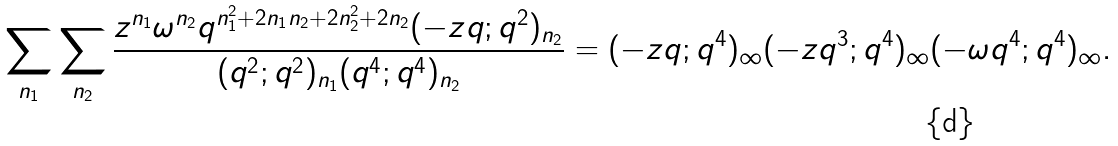Convert formula to latex. <formula><loc_0><loc_0><loc_500><loc_500>\sum _ { n _ { 1 } } \sum _ { n _ { 2 } } \frac { z ^ { n _ { 1 } } { \omega } ^ { n _ { 2 } } q ^ { n ^ { 2 } _ { 1 } + 2 n _ { 1 } n _ { 2 } + 2 n ^ { 2 } _ { 2 } + 2 n _ { 2 } } ( - z q ; q ^ { 2 } ) _ { n _ { 2 } } } { ( q ^ { 2 } ; q ^ { 2 } ) _ { n _ { 1 } } ( q ^ { 4 } ; q ^ { 4 } ) _ { n _ { 2 } } } = ( - z q ; q ^ { 4 } ) _ { \infty } ( - z q ^ { 3 } ; q ^ { 4 } ) _ { \infty } ( - \omega q ^ { 4 } ; q ^ { 4 } ) _ { \infty } .</formula> 